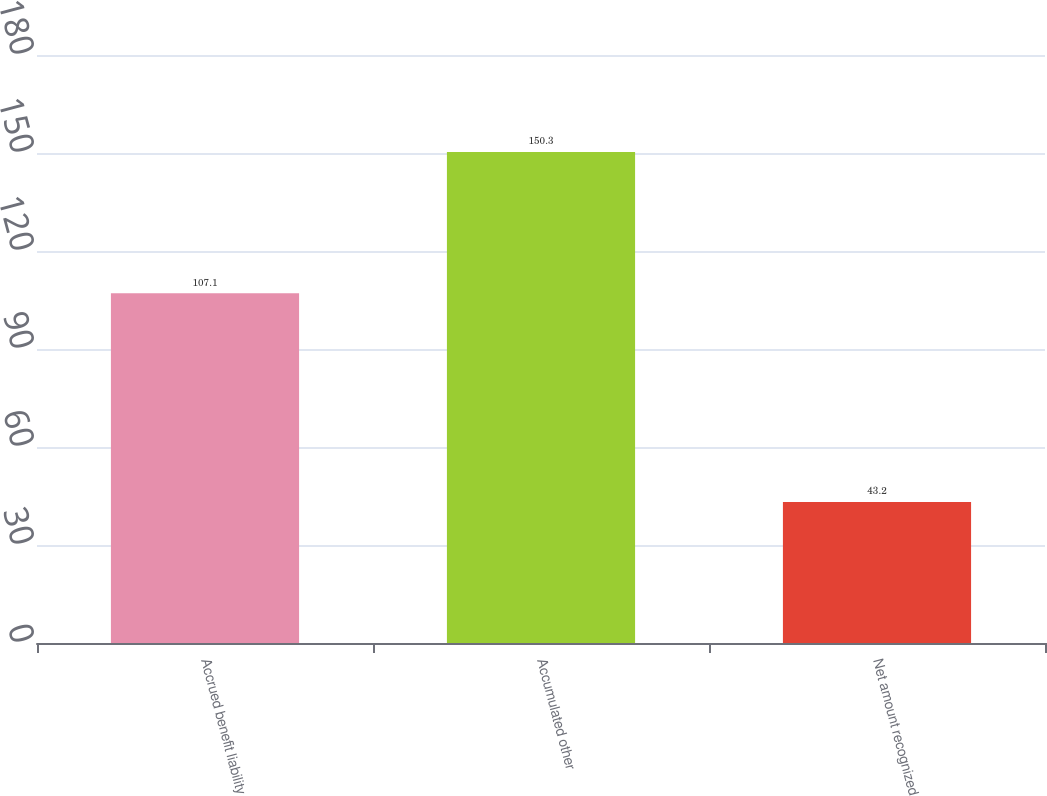Convert chart to OTSL. <chart><loc_0><loc_0><loc_500><loc_500><bar_chart><fcel>Accrued benefit liability<fcel>Accumulated other<fcel>Net amount recognized<nl><fcel>107.1<fcel>150.3<fcel>43.2<nl></chart> 